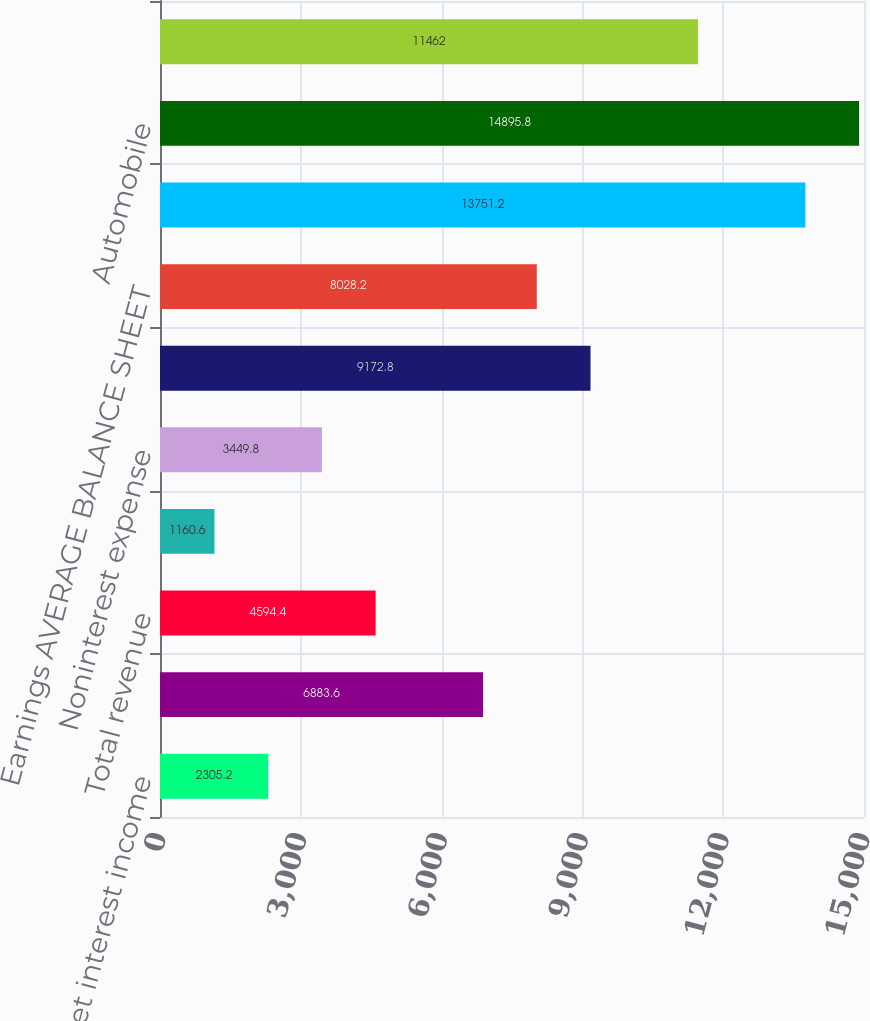Convert chart to OTSL. <chart><loc_0><loc_0><loc_500><loc_500><bar_chart><fcel>Net interest income<fcel>Noninterest income<fcel>Total revenue<fcel>Provision for credit losses<fcel>Noninterest expense<fcel>Pretax earnings Income taxes<fcel>Earnings AVERAGE BALANCE SHEET<fcel>Home equity<fcel>Automobile<fcel>Education<nl><fcel>2305.2<fcel>6883.6<fcel>4594.4<fcel>1160.6<fcel>3449.8<fcel>9172.8<fcel>8028.2<fcel>13751.2<fcel>14895.8<fcel>11462<nl></chart> 